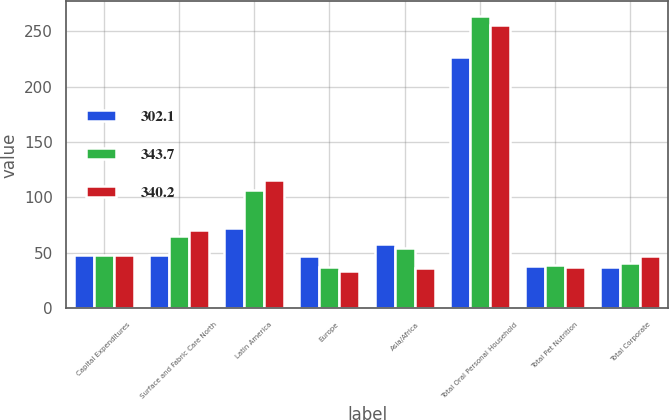<chart> <loc_0><loc_0><loc_500><loc_500><stacked_bar_chart><ecel><fcel>Capital Expenditures<fcel>Surface and Fabric Care North<fcel>Latin America<fcel>Europe<fcel>Asia/Africa<fcel>Total Oral Personal Household<fcel>Total Pet Nutrition<fcel>Total Corporate<nl><fcel>302.1<fcel>48.3<fcel>48.3<fcel>72.9<fcel>47.4<fcel>58.1<fcel>226.7<fcel>38.3<fcel>37.1<nl><fcel>343.7<fcel>48.3<fcel>65<fcel>106.4<fcel>37.7<fcel>54.6<fcel>263.7<fcel>39.4<fcel>40.6<nl><fcel>340.2<fcel>48.3<fcel>70.5<fcel>115.6<fcel>33.3<fcel>36.5<fcel>255.9<fcel>37<fcel>47.3<nl></chart> 